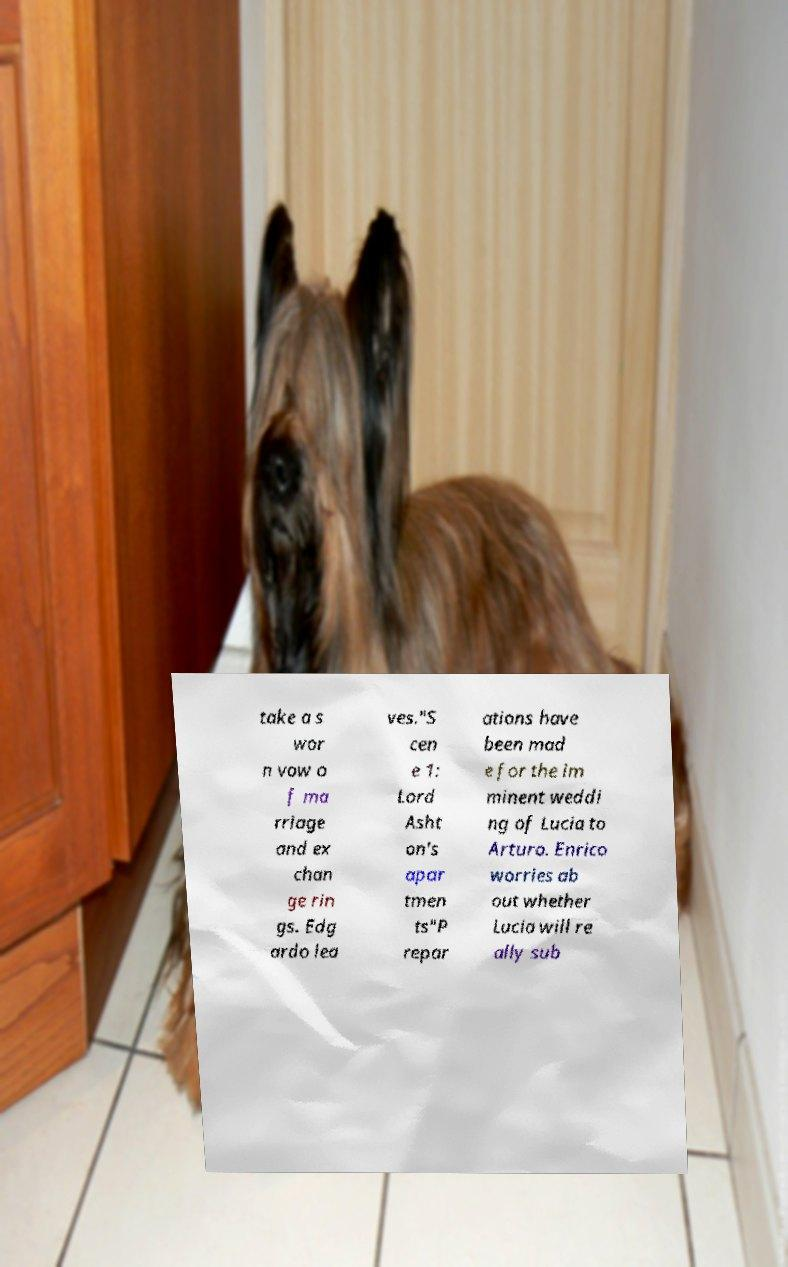Can you read and provide the text displayed in the image?This photo seems to have some interesting text. Can you extract and type it out for me? take a s wor n vow o f ma rriage and ex chan ge rin gs. Edg ardo lea ves."S cen e 1: Lord Asht on's apar tmen ts"P repar ations have been mad e for the im minent weddi ng of Lucia to Arturo. Enrico worries ab out whether Lucia will re ally sub 